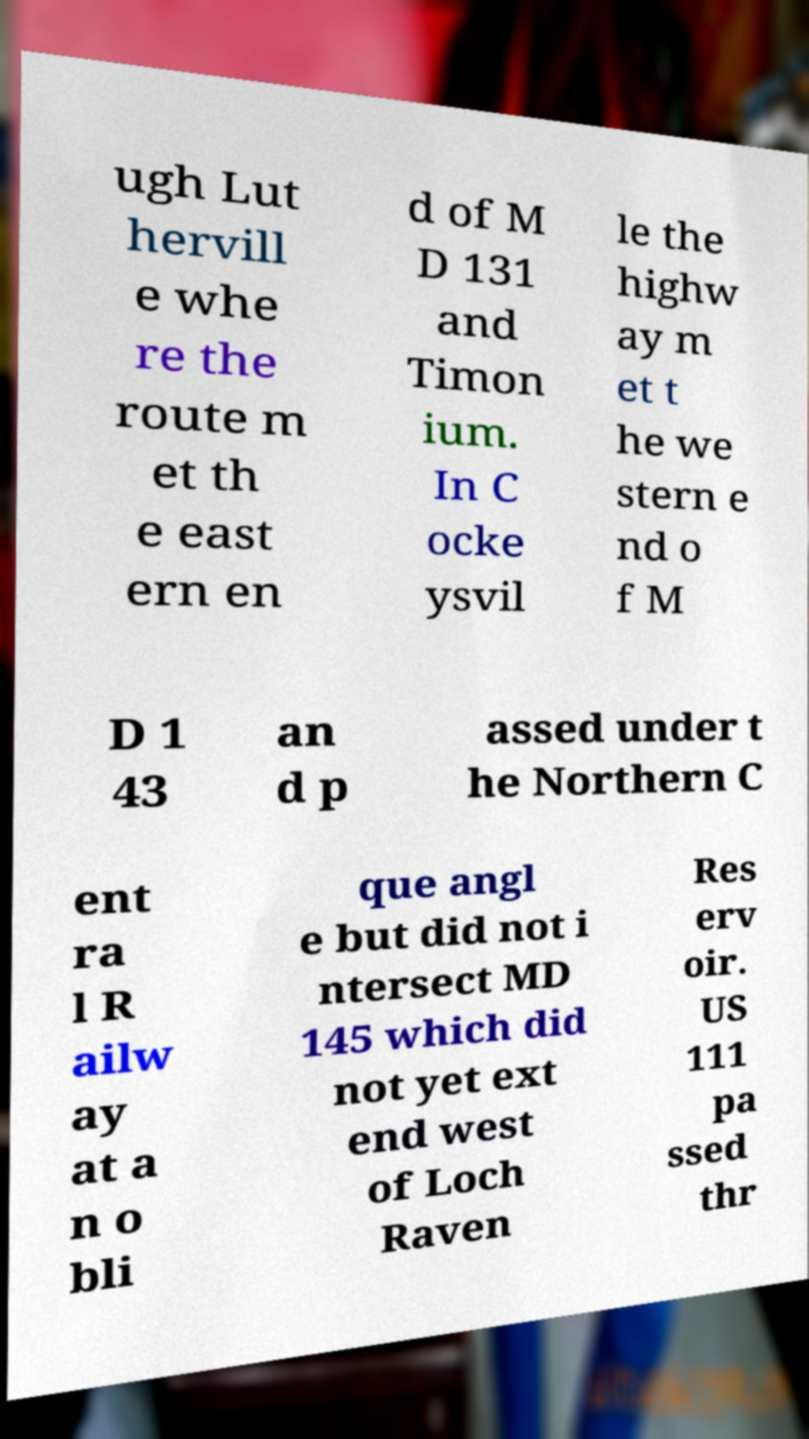Could you extract and type out the text from this image? ugh Lut hervill e whe re the route m et th e east ern en d of M D 131 and Timon ium. In C ocke ysvil le the highw ay m et t he we stern e nd o f M D 1 43 an d p assed under t he Northern C ent ra l R ailw ay at a n o bli que angl e but did not i ntersect MD 145 which did not yet ext end west of Loch Raven Res erv oir. US 111 pa ssed thr 